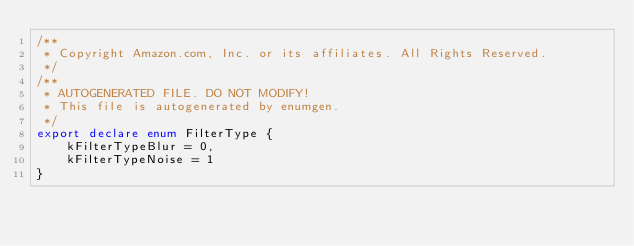<code> <loc_0><loc_0><loc_500><loc_500><_TypeScript_>/**
 * Copyright Amazon.com, Inc. or its affiliates. All Rights Reserved.
 */
/**
 * AUTOGENERATED FILE. DO NOT MODIFY!
 * This file is autogenerated by enumgen.
 */
export declare enum FilterType {
    kFilterTypeBlur = 0,
    kFilterTypeNoise = 1
}
</code> 